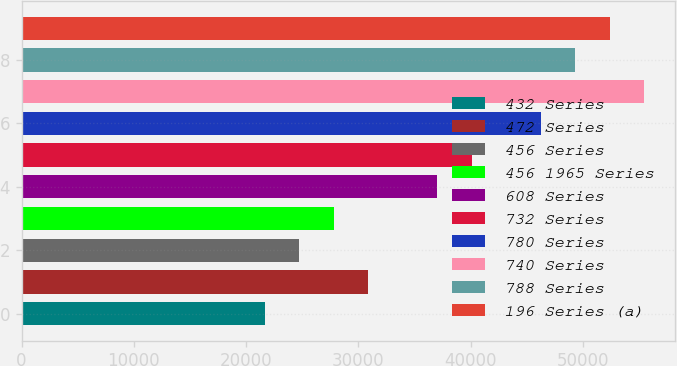Convert chart to OTSL. <chart><loc_0><loc_0><loc_500><loc_500><bar_chart><fcel>432 Series<fcel>472 Series<fcel>456 Series<fcel>456 1965 Series<fcel>608 Series<fcel>732 Series<fcel>780 Series<fcel>740 Series<fcel>788 Series<fcel>196 Series (a)<nl><fcel>21667.9<fcel>30883<fcel>24739.6<fcel>27811.3<fcel>37026.4<fcel>40098.1<fcel>46241.5<fcel>55456.6<fcel>49313.2<fcel>52384.9<nl></chart> 